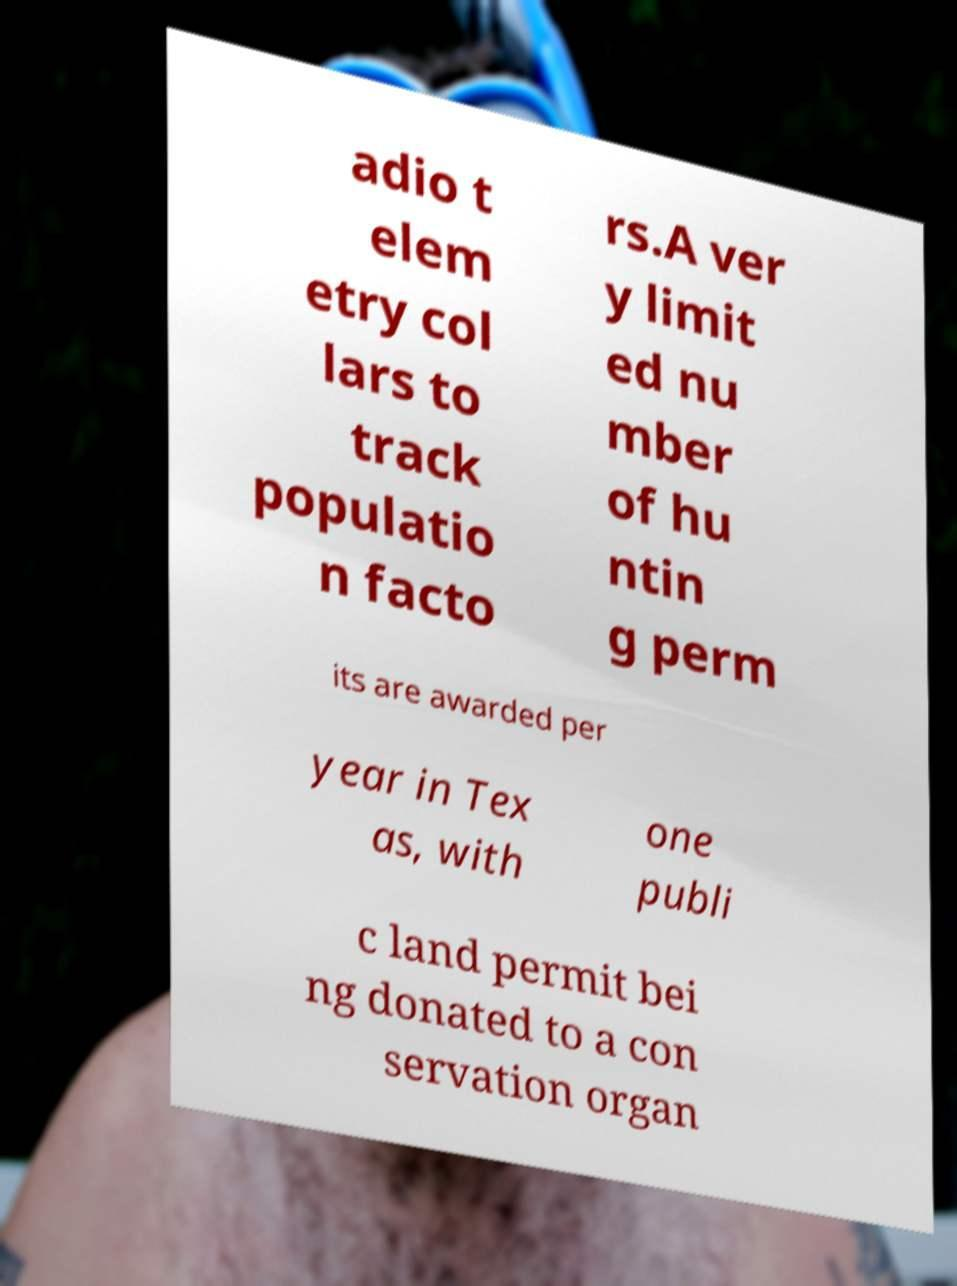I need the written content from this picture converted into text. Can you do that? adio t elem etry col lars to track populatio n facto rs.A ver y limit ed nu mber of hu ntin g perm its are awarded per year in Tex as, with one publi c land permit bei ng donated to a con servation organ 